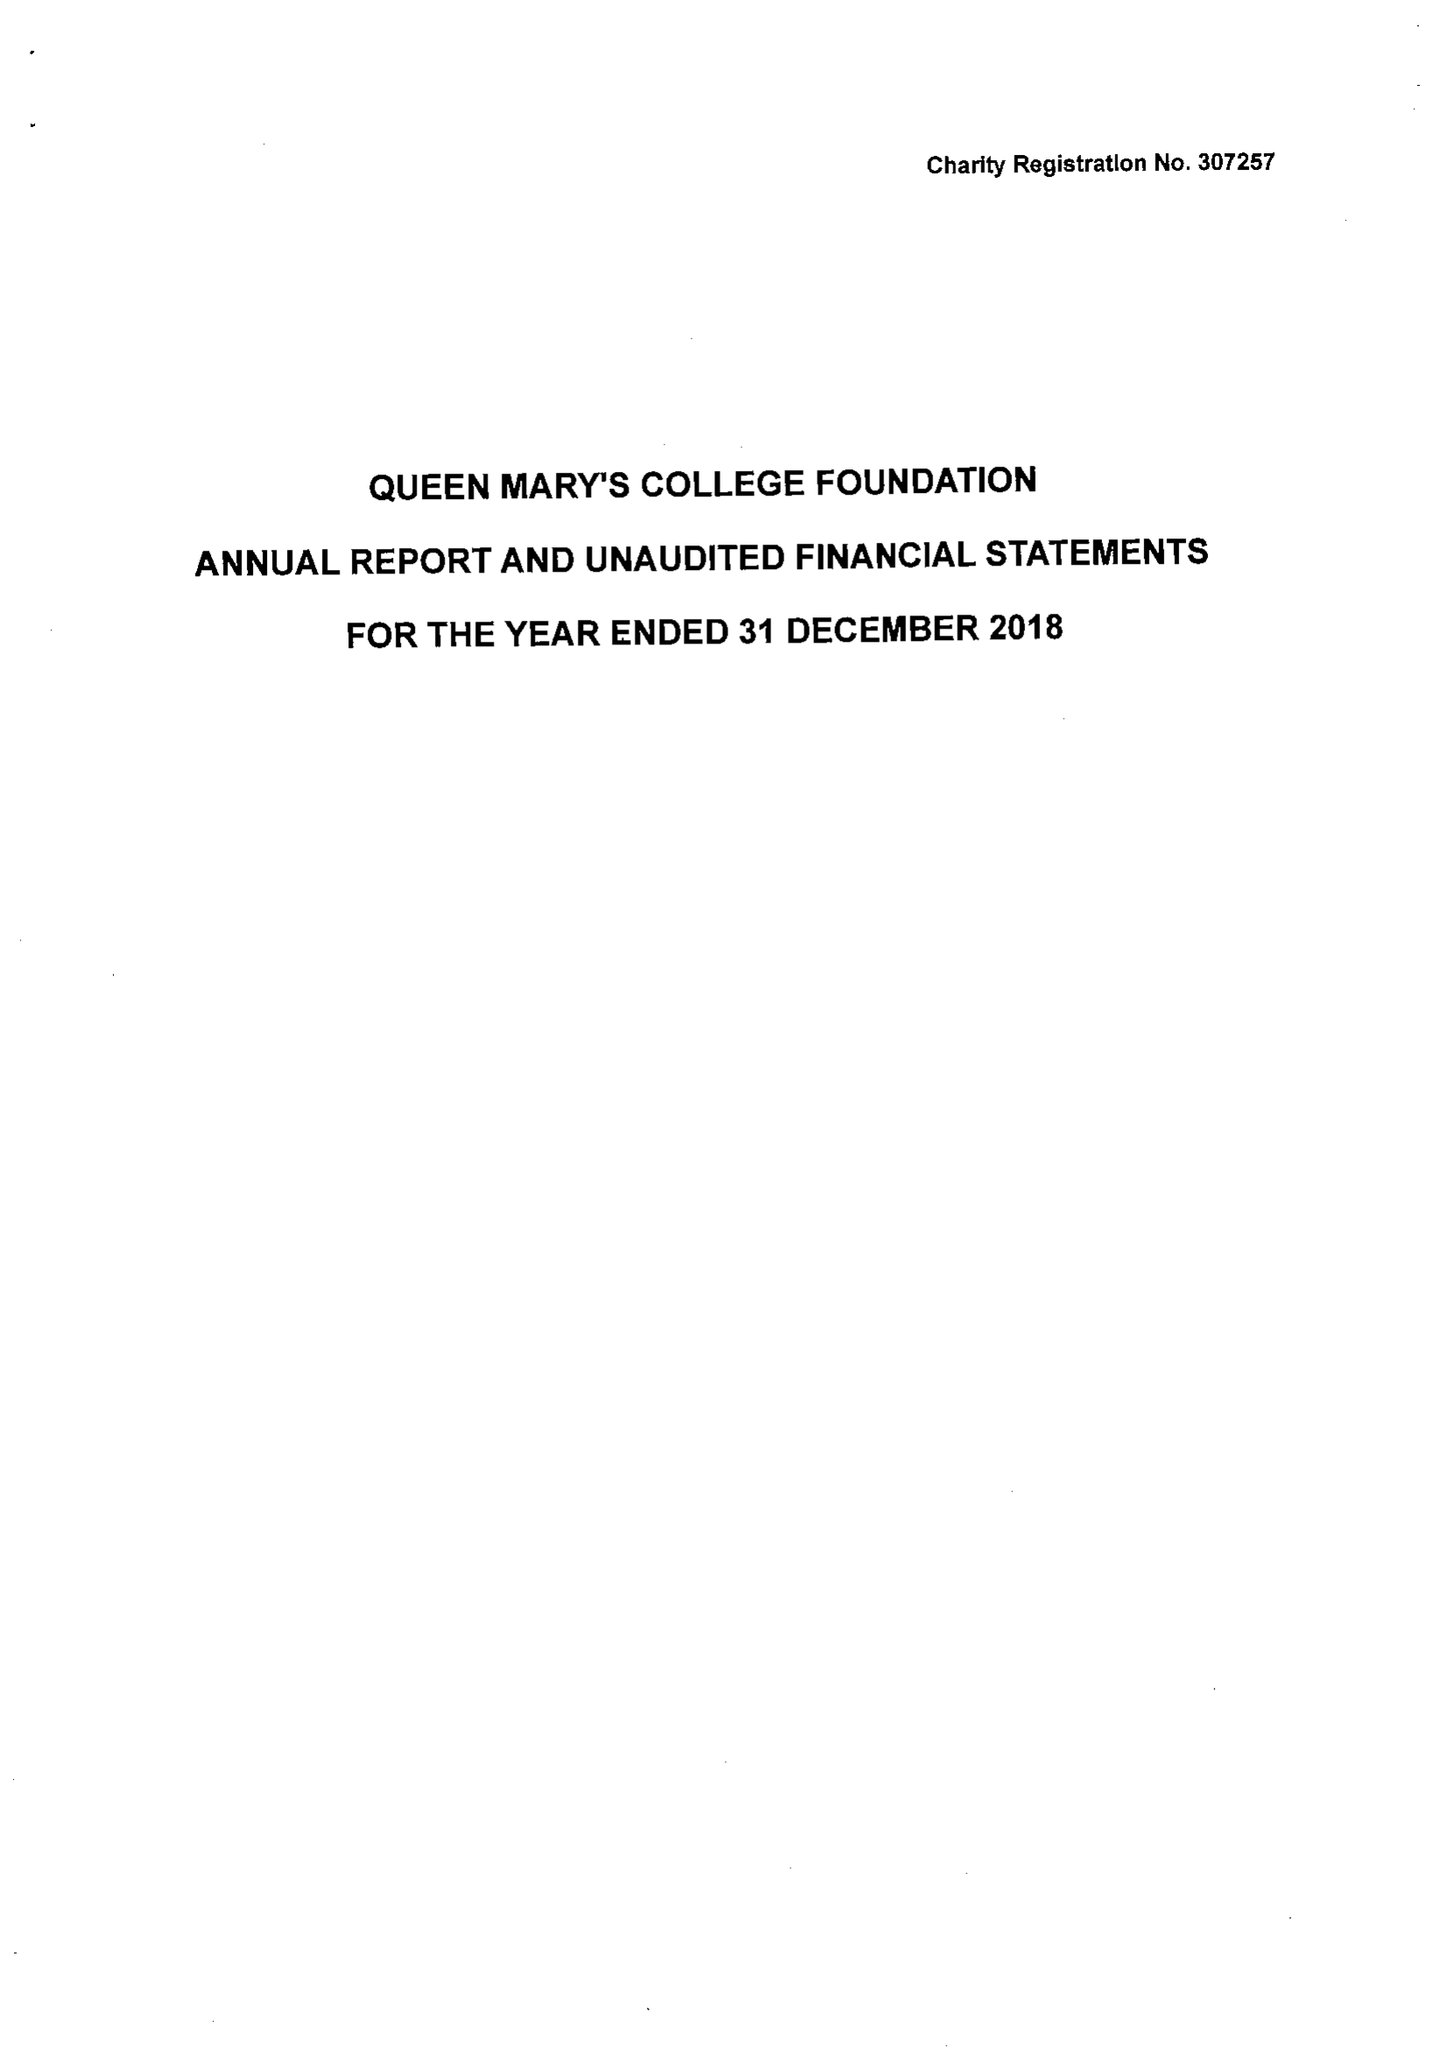What is the value for the charity_name?
Answer the question using a single word or phrase. Queen Mary's College Foundation 